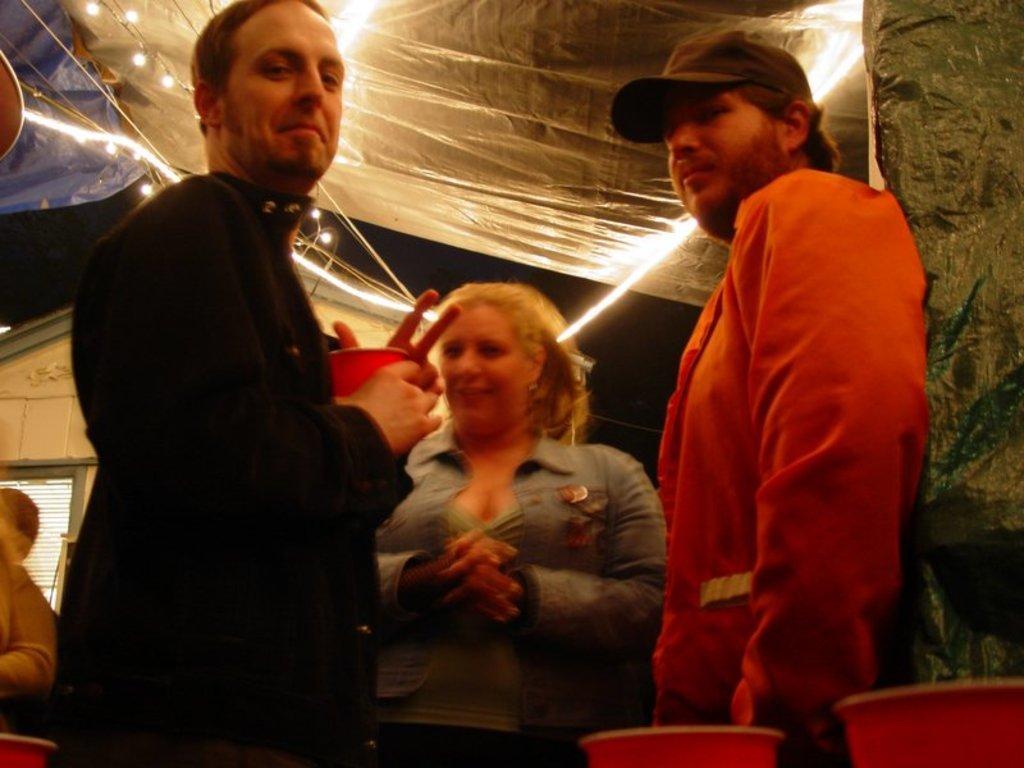How would you summarize this image in a sentence or two? In the image we can see there are people standing and wearing clothes. The right side man is wearing the cap and the left side man is holding a glass in hand. Here we can see the glasses, tent, tiny lights, house and the dark sky. 